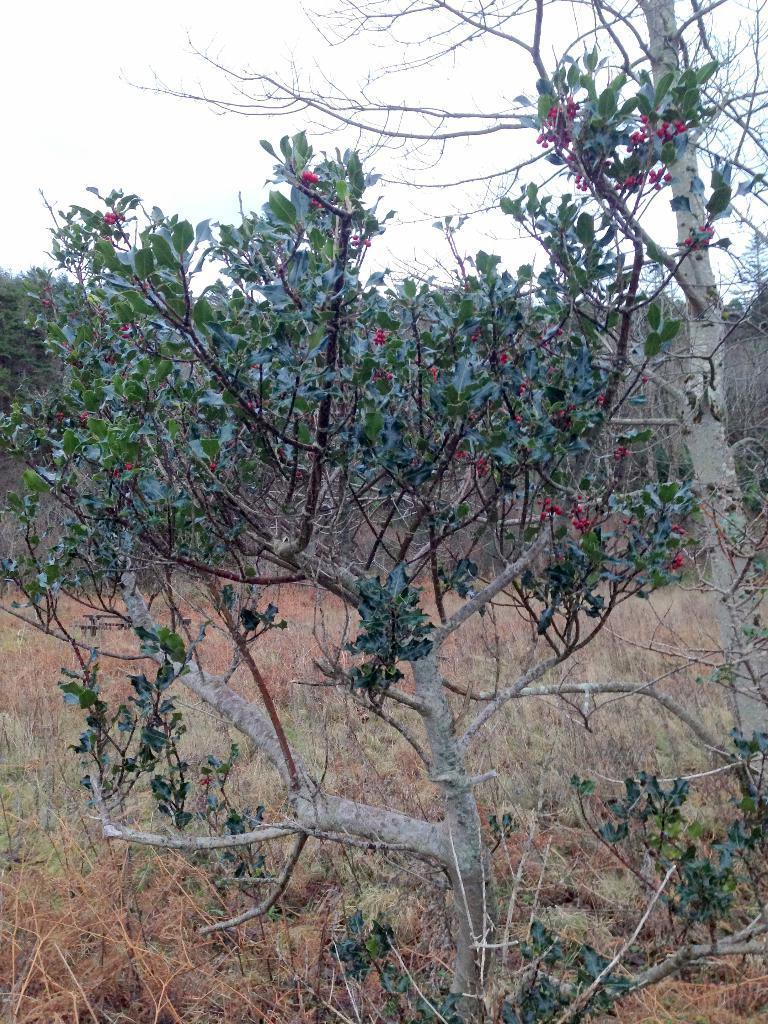Can you describe this image briefly? In this picture we can see trees, grass and we can see sky in the background. 